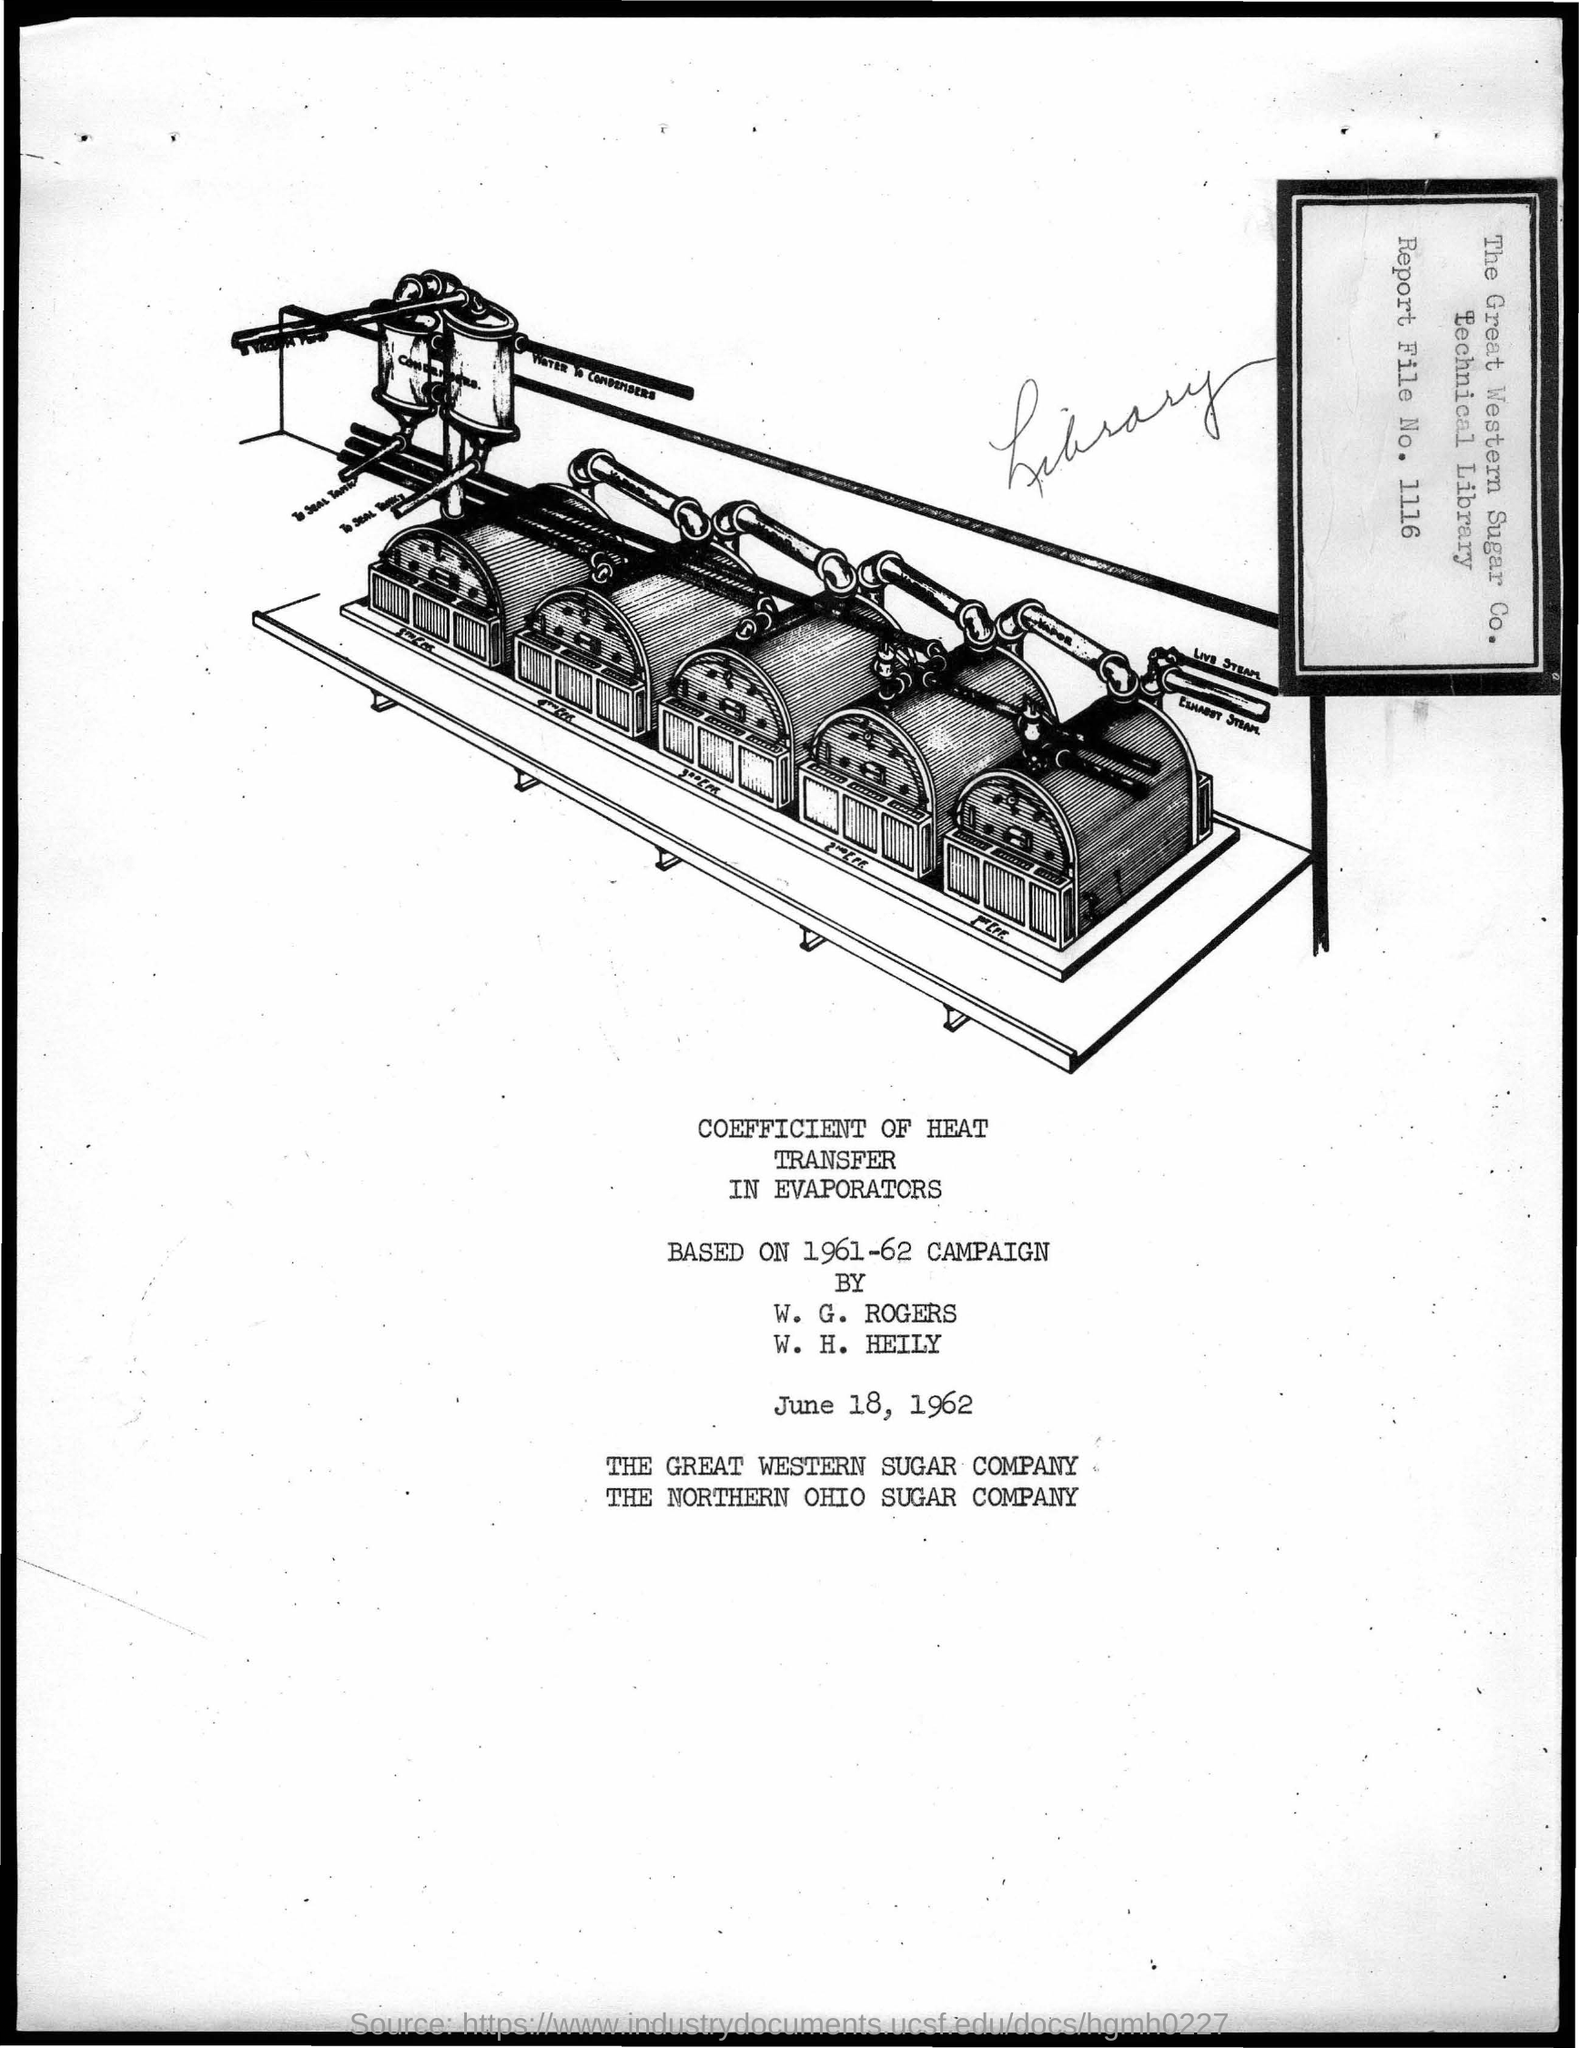Draw attention to some important aspects in this diagram. The date mentioned in the document is June 18, 1962. The report file number is 1116. 